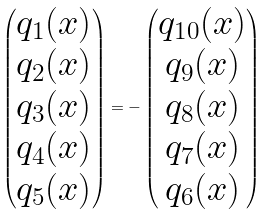Convert formula to latex. <formula><loc_0><loc_0><loc_500><loc_500>\begin{pmatrix} q _ { 1 } ( x ) \\ q _ { 2 } ( x ) \\ q _ { 3 } ( x ) \\ q _ { 4 } ( x ) \\ q _ { 5 } ( x ) \end{pmatrix} = - \begin{pmatrix} q _ { 1 0 } ( x ) \\ q _ { 9 } ( x ) \\ q _ { 8 } ( x ) \\ q _ { 7 } ( x ) \\ q _ { 6 } ( x ) \end{pmatrix}</formula> 